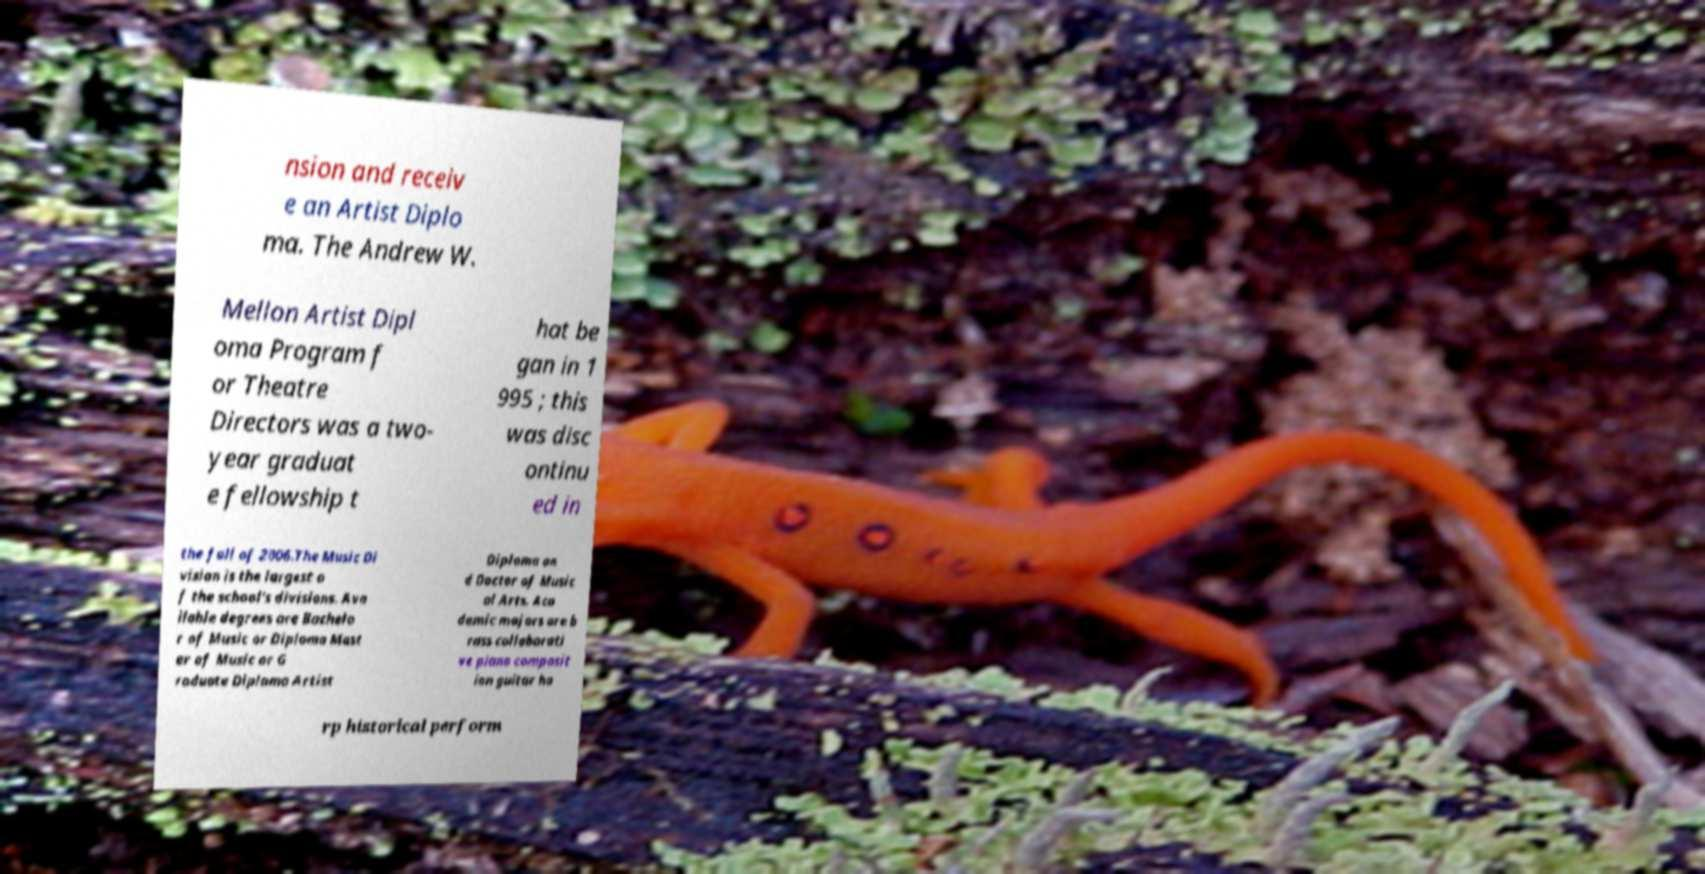Could you extract and type out the text from this image? nsion and receiv e an Artist Diplo ma. The Andrew W. Mellon Artist Dipl oma Program f or Theatre Directors was a two- year graduat e fellowship t hat be gan in 1 995 ; this was disc ontinu ed in the fall of 2006.The Music Di vision is the largest o f the school's divisions. Ava ilable degrees are Bachelo r of Music or Diploma Mast er of Music or G raduate Diploma Artist Diploma an d Doctor of Music al Arts. Aca demic majors are b rass collaborati ve piano composit ion guitar ha rp historical perform 